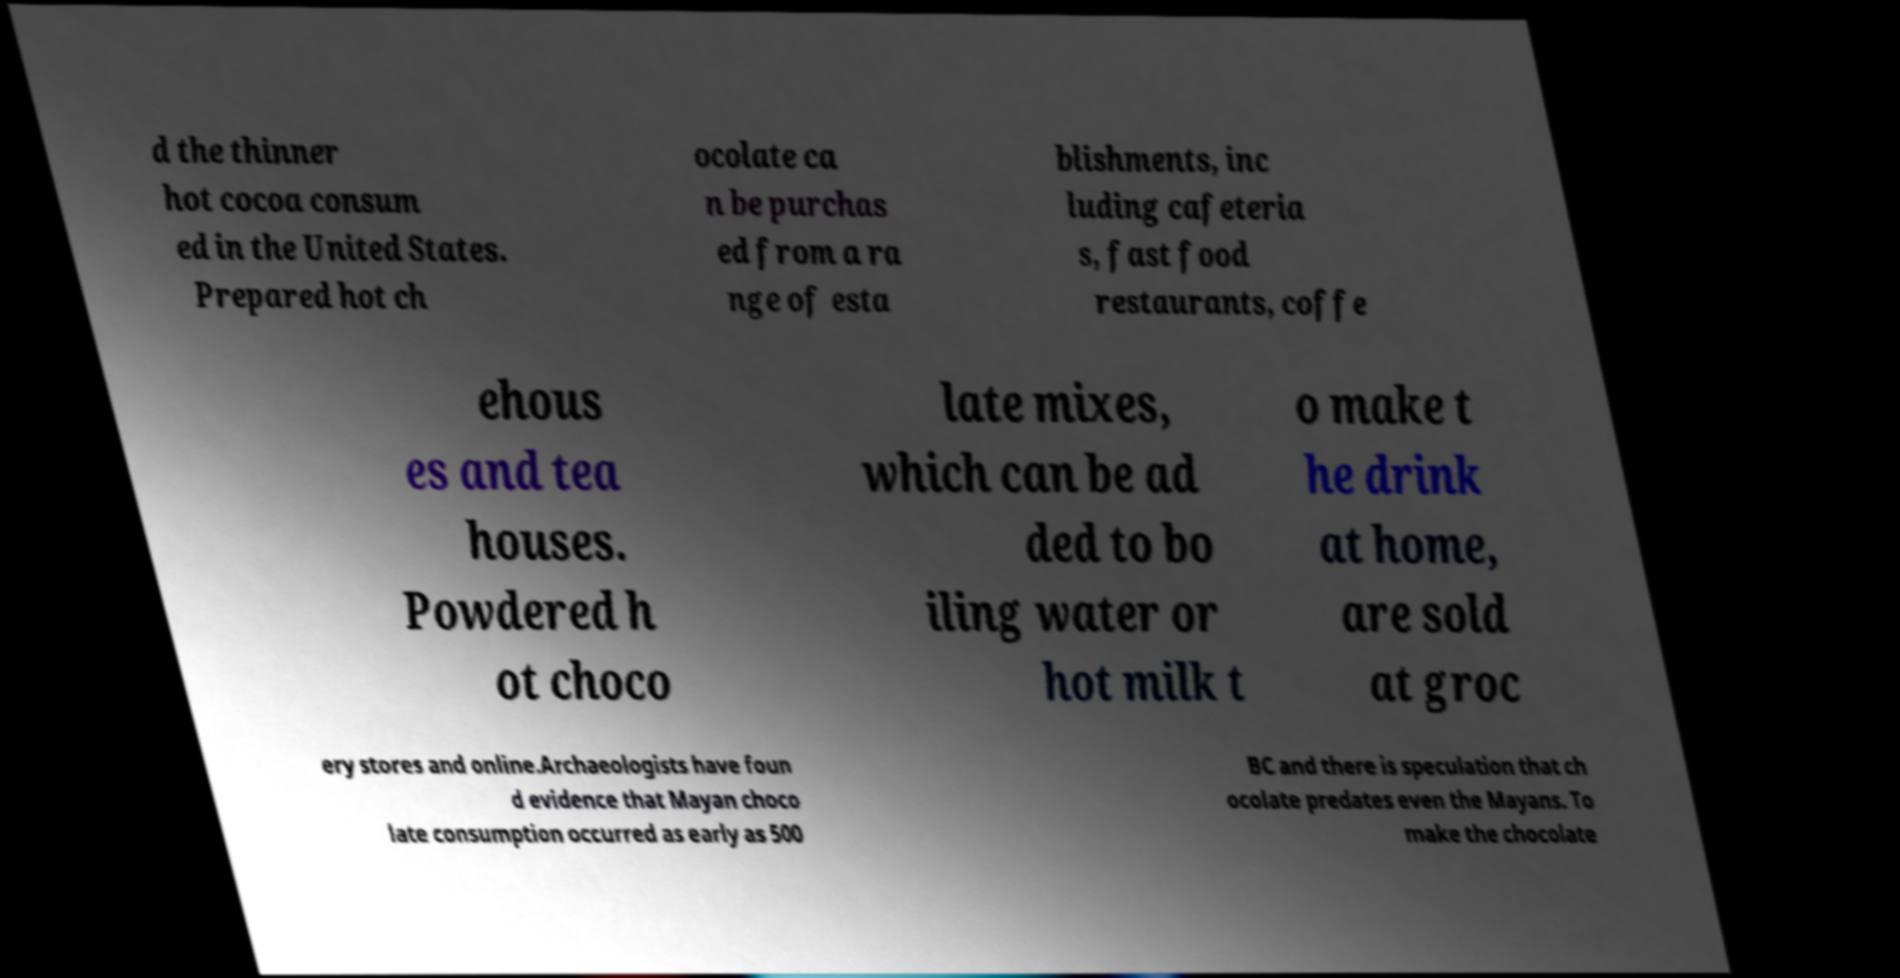Can you read and provide the text displayed in the image?This photo seems to have some interesting text. Can you extract and type it out for me? d the thinner hot cocoa consum ed in the United States. Prepared hot ch ocolate ca n be purchas ed from a ra nge of esta blishments, inc luding cafeteria s, fast food restaurants, coffe ehous es and tea houses. Powdered h ot choco late mixes, which can be ad ded to bo iling water or hot milk t o make t he drink at home, are sold at groc ery stores and online.Archaeologists have foun d evidence that Mayan choco late consumption occurred as early as 500 BC and there is speculation that ch ocolate predates even the Mayans. To make the chocolate 